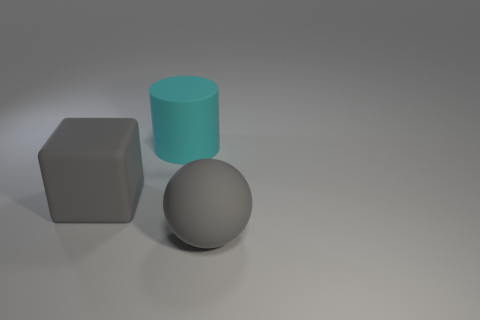Add 1 large gray shiny cylinders. How many objects exist? 4 Subtract all blocks. How many objects are left? 2 Add 1 big gray rubber objects. How many big gray rubber objects exist? 3 Subtract 0 red cylinders. How many objects are left? 3 Subtract all small gray rubber balls. Subtract all large gray rubber things. How many objects are left? 1 Add 1 gray objects. How many gray objects are left? 3 